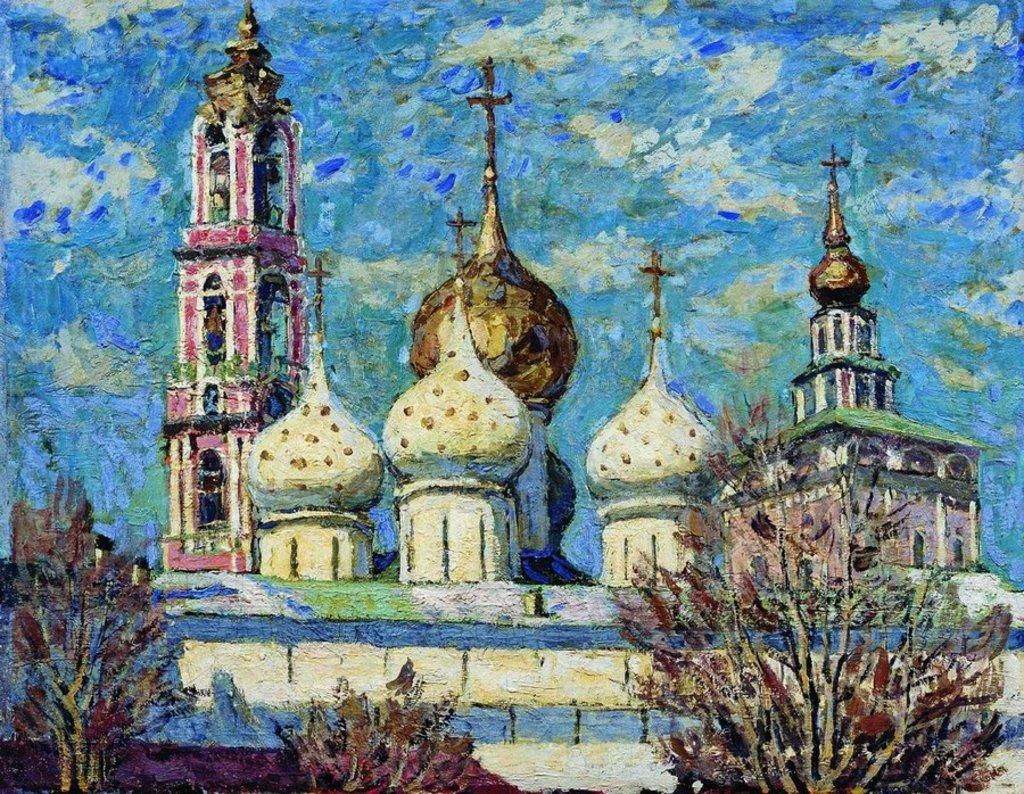What is the main subject of the painting in the image? The main subject of the painting in the image is a church. Are there any other elements present in the painting besides the church? Yes, there are trees depicted in the image. What type of fruit is hanging from the trees in the image? There are no trees with fruit in the image; the trees depicted are not bearing fruit. 